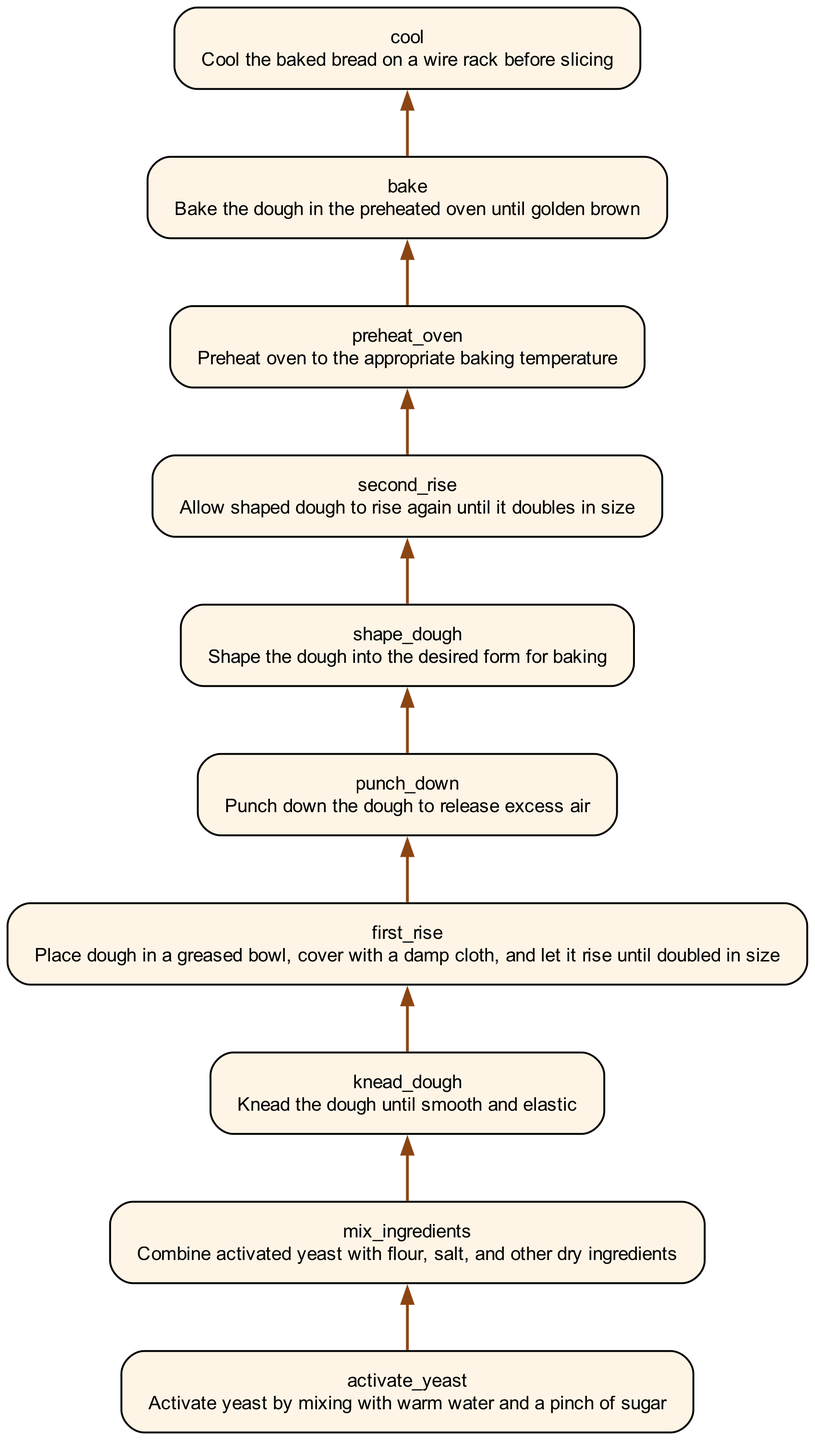What is the first step in the dough preparation process? The diagram shows that the first step is "Activate yeast by mixing with warm water and a pinch of sugar," indicated as the bottommost node.
Answer: Activate yeast by mixing with warm water and a pinch of sugar How many steps are involved in the dough preparation and rising process? The diagram lists a total of 10 nodes, each representing a distinct step in the process, from activating yeast to cooling the baked bread.
Answer: 10 What is the purpose of the "punch down" step? According to the diagram, the "Punch down" step is described as releasing excess air from the dough, which is critical for proper texture.
Answer: Release excess air What is the relationship between "knead dough" and "first rise"? The diagram shows a direct flow from "knead dough" to "first rise," meaning that kneading is completed before the dough rises for the first time.
Answer: Knead dough leads to first rise What do you do after the "second rise"? The diagram indicates that after the "second rise," the next step is to "preheat oven," meaning that you prepare the oven for baking after allowing the dough to rise again.
Answer: Preheat oven How many times does the dough rise during the preparation process? The diagram outlines two distinct rising steps: "first rise" and "second rise," indicating that the dough rises twice during the process.
Answer: 2 What is the last step in the dough preparation process? The last node shown in the diagram states "Cool," indicating that the final step is to cool the baked bread on a wire rack before slicing.
Answer: Cool What happens after the dough is shaped? Referring to the diagram, once the dough is shaped, it undergoes a "second rise" before any further baking steps can be taken.
Answer: Second rise What is the action taken before baking the dough? The diagram clearly states that the step preceding baking is "preheat oven," which means the oven should be prepared before placing the dough inside.
Answer: Preheat oven 